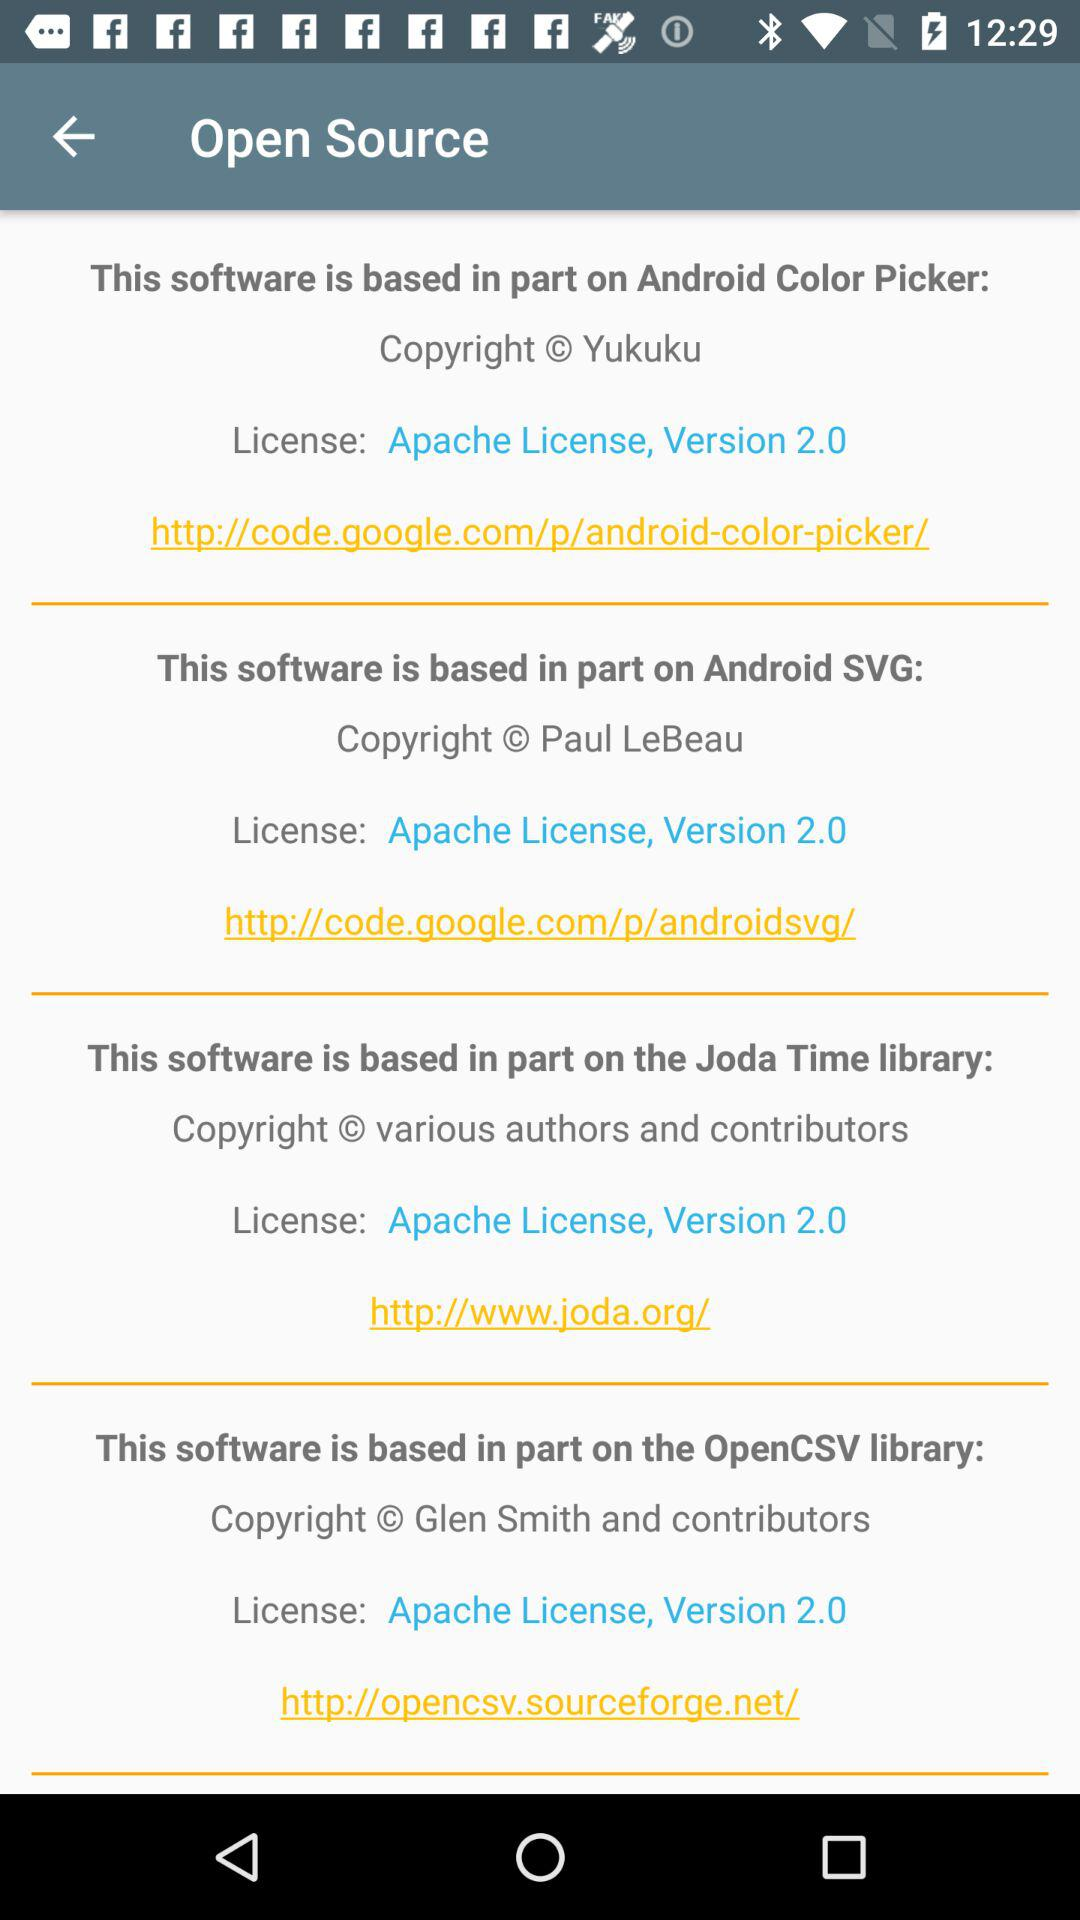What is the copyright of the Android Color Picker? The copyright is Yukuku. 